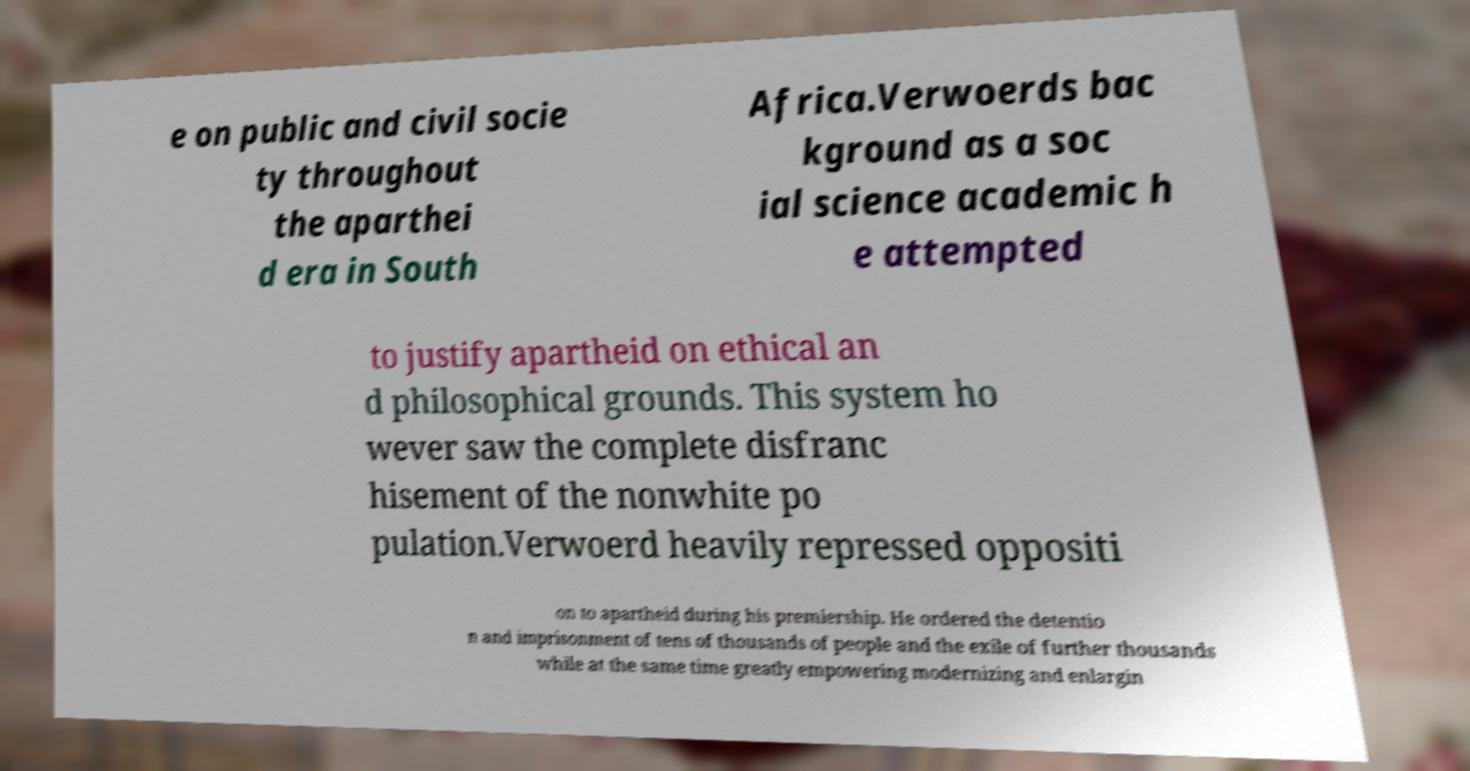What messages or text are displayed in this image? I need them in a readable, typed format. e on public and civil socie ty throughout the aparthei d era in South Africa.Verwoerds bac kground as a soc ial science academic h e attempted to justify apartheid on ethical an d philosophical grounds. This system ho wever saw the complete disfranc hisement of the nonwhite po pulation.Verwoerd heavily repressed oppositi on to apartheid during his premiership. He ordered the detentio n and imprisonment of tens of thousands of people and the exile of further thousands while at the same time greatly empowering modernizing and enlargin 